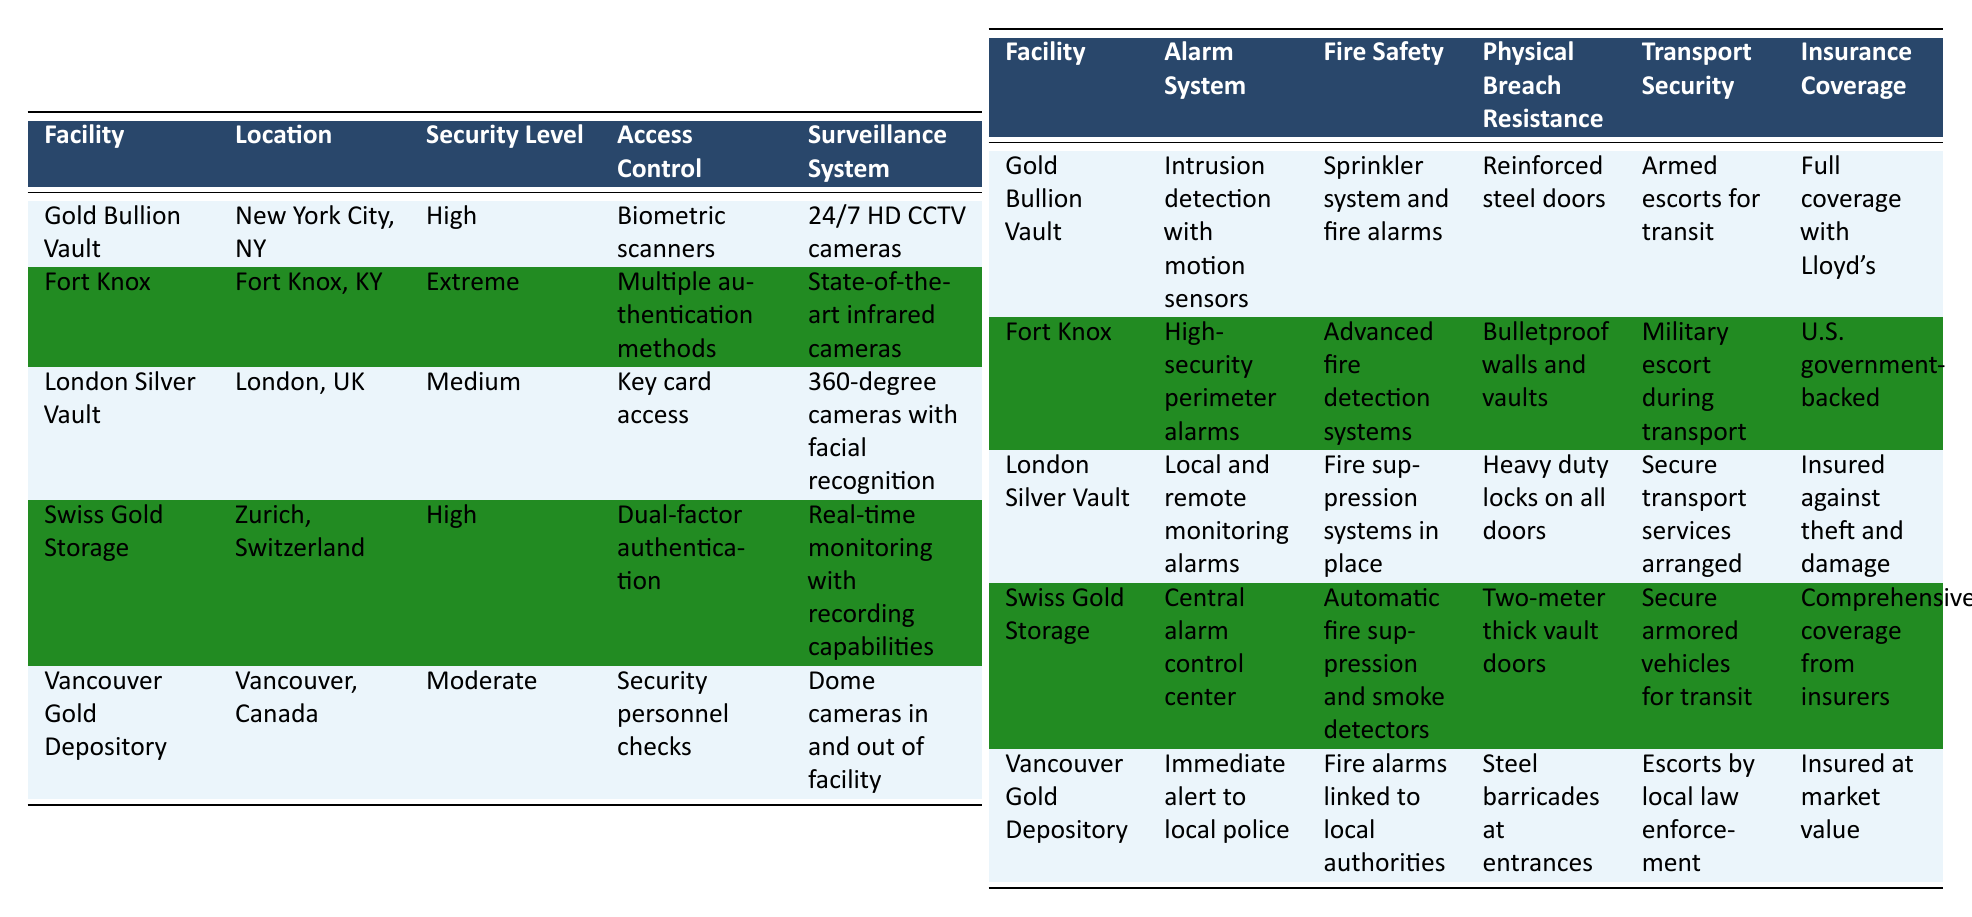What is the location of Fort Knox? The table lists Fort Knox under the "Location" column, showing its specific location as Fort Knox, KY.
Answer: Fort Knox, KY Which facility has the highest security level? The table provides a "Security Level" column, where "Fort Knox" is marked with the highest security level, labeled as "Extreme".
Answer: Fort Knox Do all facilities have fire safety measures in place? Examining the "Fire Safety" column, each facility has specific measures noted, indicating that yes, all have fire safety measures in place.
Answer: Yes Which facility offers armed escorts for transport? By reviewing the "Transport Security" column, only the "Gold Bullion Vault" and "Fort Knox" specifically mention that armed escorts are present during transport.
Answer: Gold Bullion Vault and Fort Knox How many facilities use biometric access control? The "Access Control" column indicates that only the "Gold Bullion Vault" uses biometric scanners for access, making this a single facility.
Answer: 1 What is the insurance coverage for the Vancouver Gold Depository? Looking at the "Insurance Coverage" column, the Vancouver Gold Depository is listed as insured at market value.
Answer: Insured at market value Which facility has the weakest physical breach resistance? The comparison of the "Physical Breach Resistance" column shows that the "London Silver Vault" features heavy duty locks, which are less robust than the bulletproof or two-meter thick options of other facilities.
Answer: London Silver Vault Do any facilities have surveillance systems without cameras? The "Surveillance System" column reveals that all listed facilities utilize camera systems, indicating that none operate without cameras.
Answer: No What security level is associated with the Swiss Gold Storage? Checking the "Security Level" column, Swiss Gold Storage is categorized with a high security level.
Answer: High Is there any facility that has military escorts for both transport and security checks? Analyzing the related columns shows that military escorts are specifically noted in the "Transport Security" for "Fort Knox" only, whereas other facilities like "Vancouver Gold Depository" employ local law enforcement rather than military.
Answer: No Which facility has a comprehensive emergency response plan? By identifying the facilities from the "Emergency Procedures" column, "Fort Knox" is specifically noted to have comprehensive response plans.
Answer: Fort Knox 